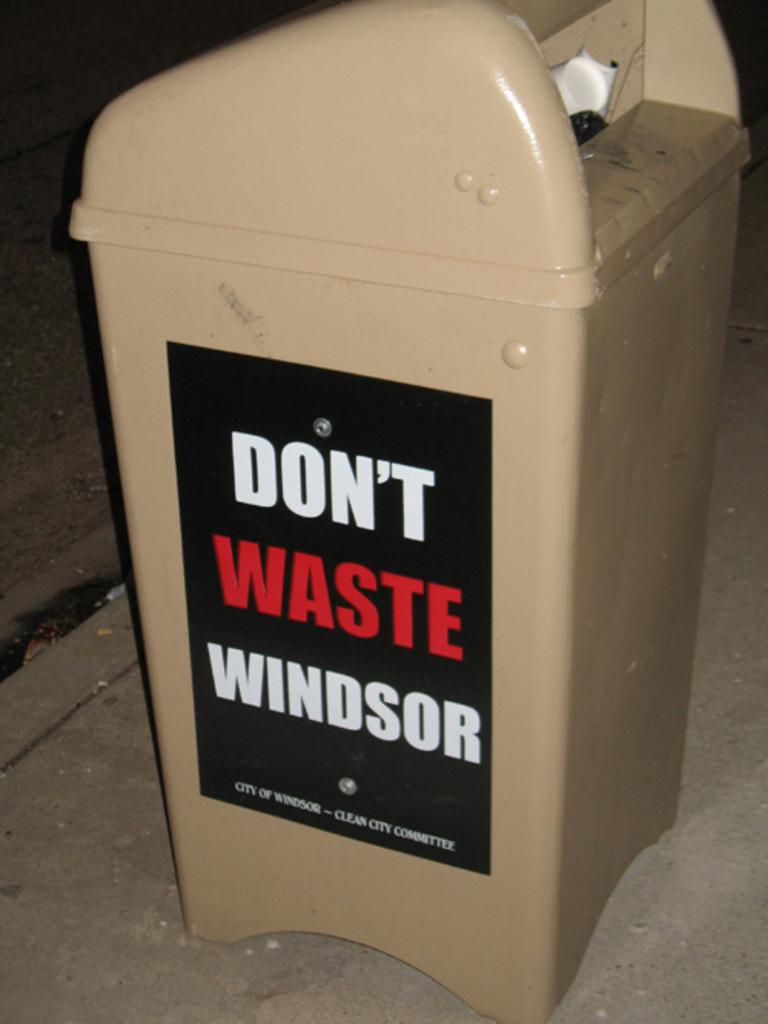What city is this can in?
Provide a short and direct response. Windsor. 